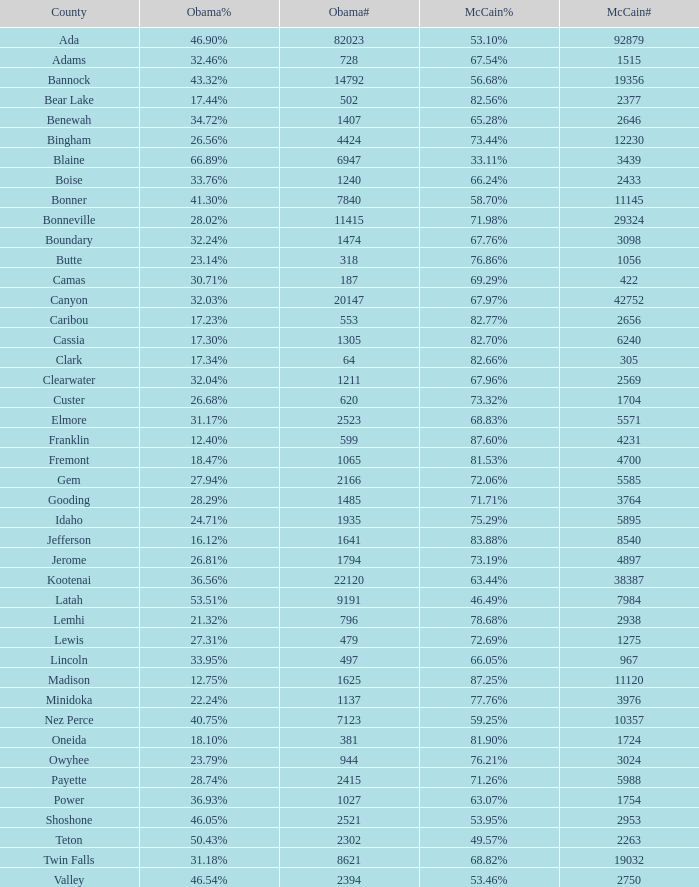In jerome county, what is the percentage of votes for mccain? 73.19%. 